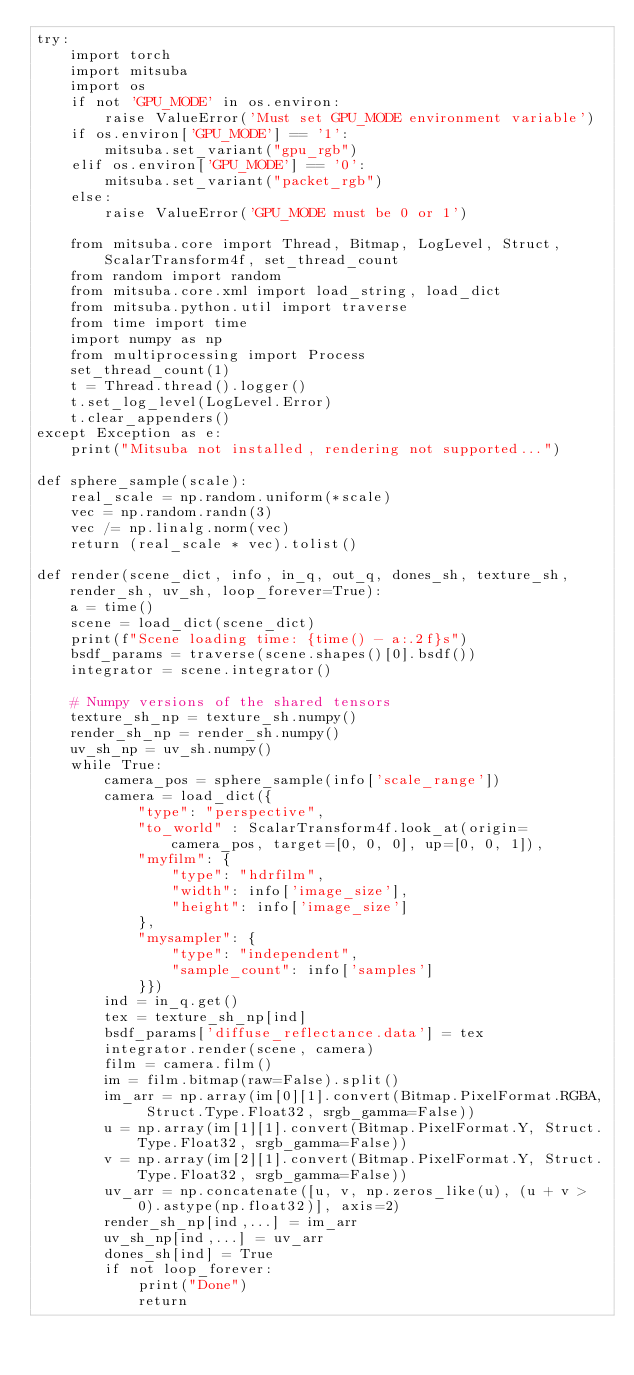Convert code to text. <code><loc_0><loc_0><loc_500><loc_500><_Python_>try:
    import torch
    import mitsuba 
    import os
    if not 'GPU_MODE' in os.environ:
        raise ValueError('Must set GPU_MODE environment variable')
    if os.environ['GPU_MODE'] == '1':
        mitsuba.set_variant("gpu_rgb")
    elif os.environ['GPU_MODE'] == '0':
        mitsuba.set_variant("packet_rgb")
    else:
        raise ValueError('GPU_MODE must be 0 or 1')

    from mitsuba.core import Thread, Bitmap, LogLevel, Struct, ScalarTransform4f, set_thread_count
    from random import random
    from mitsuba.core.xml import load_string, load_dict
    from mitsuba.python.util import traverse
    from time import time
    import numpy as np
    from multiprocessing import Process
    set_thread_count(1)
    t = Thread.thread().logger()
    t.set_log_level(LogLevel.Error)
    t.clear_appenders()
except Exception as e:
    print("Mitsuba not installed, rendering not supported...")

def sphere_sample(scale):
    real_scale = np.random.uniform(*scale)
    vec = np.random.randn(3)
    vec /= np.linalg.norm(vec)
    return (real_scale * vec).tolist()

def render(scene_dict, info, in_q, out_q, dones_sh, texture_sh, render_sh, uv_sh, loop_forever=True):
    a = time()
    scene = load_dict(scene_dict)
    print(f"Scene loading time: {time() - a:.2f}s")
    bsdf_params = traverse(scene.shapes()[0].bsdf())
    integrator = scene.integrator()

    # Numpy versions of the shared tensors
    texture_sh_np = texture_sh.numpy()
    render_sh_np = render_sh.numpy()
    uv_sh_np = uv_sh.numpy()
    while True:
        camera_pos = sphere_sample(info['scale_range'])
        camera = load_dict({
            "type": "perspective",
            "to_world" : ScalarTransform4f.look_at(origin=camera_pos, target=[0, 0, 0], up=[0, 0, 1]),
            "myfilm": {
                "type": "hdrfilm",
                "width": info['image_size'],
                "height": info['image_size']
            },
            "mysampler": {
                "type": "independent",
                "sample_count": info['samples']
            }})
        ind = in_q.get()
        tex = texture_sh_np[ind]
        bsdf_params['diffuse_reflectance.data'] = tex
        integrator.render(scene, camera)
        film = camera.film()
        im = film.bitmap(raw=False).split()
        im_arr = np.array(im[0][1].convert(Bitmap.PixelFormat.RGBA, Struct.Type.Float32, srgb_gamma=False))
        u = np.array(im[1][1].convert(Bitmap.PixelFormat.Y, Struct.Type.Float32, srgb_gamma=False))
        v = np.array(im[2][1].convert(Bitmap.PixelFormat.Y, Struct.Type.Float32, srgb_gamma=False))
        uv_arr = np.concatenate([u, v, np.zeros_like(u), (u + v > 0).astype(np.float32)], axis=2)
        render_sh_np[ind,...] = im_arr 
        uv_sh_np[ind,...] = uv_arr
        dones_sh[ind] = True
        if not loop_forever: 
            print("Done")
            return
</code> 